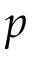Convert formula to latex. <formula><loc_0><loc_0><loc_500><loc_500>p</formula> 